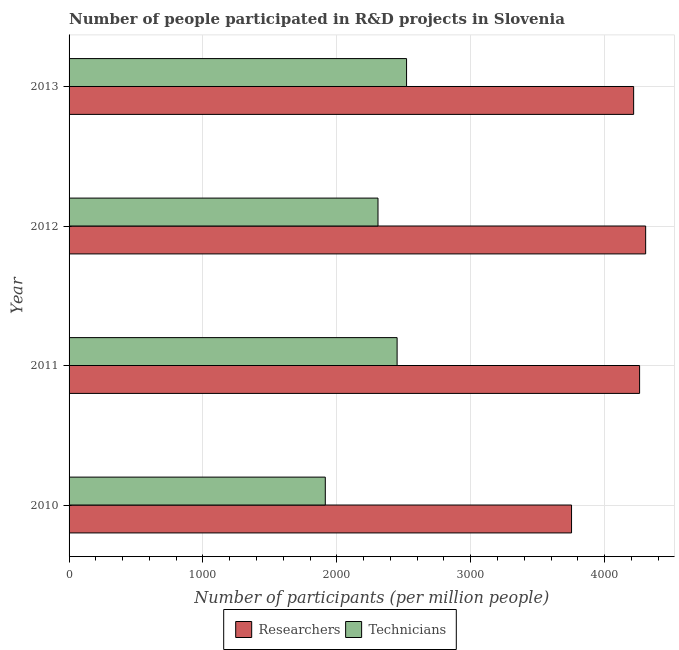How many different coloured bars are there?
Ensure brevity in your answer.  2. How many groups of bars are there?
Provide a succinct answer. 4. Are the number of bars per tick equal to the number of legend labels?
Make the answer very short. Yes. Are the number of bars on each tick of the Y-axis equal?
Keep it short and to the point. Yes. How many bars are there on the 4th tick from the top?
Provide a short and direct response. 2. How many bars are there on the 2nd tick from the bottom?
Keep it short and to the point. 2. What is the number of technicians in 2011?
Keep it short and to the point. 2450.19. Across all years, what is the maximum number of technicians?
Offer a very short reply. 2520.8. Across all years, what is the minimum number of technicians?
Make the answer very short. 1913.78. In which year was the number of researchers maximum?
Your answer should be very brief. 2012. In which year was the number of researchers minimum?
Provide a short and direct response. 2010. What is the total number of technicians in the graph?
Your answer should be very brief. 9192.23. What is the difference between the number of technicians in 2010 and that in 2013?
Your answer should be compact. -607.02. What is the difference between the number of researchers in 2012 and the number of technicians in 2010?
Make the answer very short. 2392.82. What is the average number of researchers per year?
Your answer should be very brief. 4134.42. In the year 2010, what is the difference between the number of technicians and number of researchers?
Keep it short and to the point. -1839.24. In how many years, is the number of researchers greater than 600 ?
Keep it short and to the point. 4. What is the ratio of the number of technicians in 2012 to that in 2013?
Offer a very short reply. 0.92. What is the difference between the highest and the second highest number of technicians?
Keep it short and to the point. 70.61. What is the difference between the highest and the lowest number of researchers?
Your answer should be very brief. 553.58. In how many years, is the number of researchers greater than the average number of researchers taken over all years?
Your answer should be very brief. 3. Is the sum of the number of researchers in 2011 and 2013 greater than the maximum number of technicians across all years?
Ensure brevity in your answer.  Yes. What does the 1st bar from the top in 2011 represents?
Give a very brief answer. Technicians. What does the 1st bar from the bottom in 2011 represents?
Your answer should be very brief. Researchers. What is the difference between two consecutive major ticks on the X-axis?
Give a very brief answer. 1000. Does the graph contain grids?
Your answer should be very brief. Yes. How many legend labels are there?
Your answer should be compact. 2. What is the title of the graph?
Keep it short and to the point. Number of people participated in R&D projects in Slovenia. Does "IMF concessional" appear as one of the legend labels in the graph?
Keep it short and to the point. No. What is the label or title of the X-axis?
Your answer should be compact. Number of participants (per million people). What is the Number of participants (per million people) of Researchers in 2010?
Provide a succinct answer. 3753.02. What is the Number of participants (per million people) of Technicians in 2010?
Ensure brevity in your answer.  1913.78. What is the Number of participants (per million people) in Researchers in 2011?
Keep it short and to the point. 4261.24. What is the Number of participants (per million people) of Technicians in 2011?
Provide a succinct answer. 2450.19. What is the Number of participants (per million people) in Researchers in 2012?
Offer a terse response. 4306.6. What is the Number of participants (per million people) in Technicians in 2012?
Give a very brief answer. 2307.45. What is the Number of participants (per million people) of Researchers in 2013?
Your response must be concise. 4216.83. What is the Number of participants (per million people) of Technicians in 2013?
Provide a succinct answer. 2520.8. Across all years, what is the maximum Number of participants (per million people) in Researchers?
Your answer should be very brief. 4306.6. Across all years, what is the maximum Number of participants (per million people) of Technicians?
Your answer should be compact. 2520.8. Across all years, what is the minimum Number of participants (per million people) in Researchers?
Provide a succinct answer. 3753.02. Across all years, what is the minimum Number of participants (per million people) in Technicians?
Provide a short and direct response. 1913.78. What is the total Number of participants (per million people) of Researchers in the graph?
Offer a very short reply. 1.65e+04. What is the total Number of participants (per million people) in Technicians in the graph?
Your answer should be compact. 9192.23. What is the difference between the Number of participants (per million people) in Researchers in 2010 and that in 2011?
Ensure brevity in your answer.  -508.22. What is the difference between the Number of participants (per million people) in Technicians in 2010 and that in 2011?
Ensure brevity in your answer.  -536.41. What is the difference between the Number of participants (per million people) in Researchers in 2010 and that in 2012?
Provide a succinct answer. -553.58. What is the difference between the Number of participants (per million people) in Technicians in 2010 and that in 2012?
Offer a very short reply. -393.67. What is the difference between the Number of participants (per million people) in Researchers in 2010 and that in 2013?
Provide a short and direct response. -463.81. What is the difference between the Number of participants (per million people) in Technicians in 2010 and that in 2013?
Keep it short and to the point. -607.02. What is the difference between the Number of participants (per million people) in Researchers in 2011 and that in 2012?
Provide a short and direct response. -45.35. What is the difference between the Number of participants (per million people) of Technicians in 2011 and that in 2012?
Provide a succinct answer. 142.74. What is the difference between the Number of participants (per million people) in Researchers in 2011 and that in 2013?
Your response must be concise. 44.41. What is the difference between the Number of participants (per million people) of Technicians in 2011 and that in 2013?
Your response must be concise. -70.61. What is the difference between the Number of participants (per million people) in Researchers in 2012 and that in 2013?
Offer a terse response. 89.76. What is the difference between the Number of participants (per million people) in Technicians in 2012 and that in 2013?
Your answer should be compact. -213.35. What is the difference between the Number of participants (per million people) in Researchers in 2010 and the Number of participants (per million people) in Technicians in 2011?
Keep it short and to the point. 1302.83. What is the difference between the Number of participants (per million people) in Researchers in 2010 and the Number of participants (per million people) in Technicians in 2012?
Offer a very short reply. 1445.57. What is the difference between the Number of participants (per million people) of Researchers in 2010 and the Number of participants (per million people) of Technicians in 2013?
Keep it short and to the point. 1232.22. What is the difference between the Number of participants (per million people) of Researchers in 2011 and the Number of participants (per million people) of Technicians in 2012?
Your response must be concise. 1953.79. What is the difference between the Number of participants (per million people) in Researchers in 2011 and the Number of participants (per million people) in Technicians in 2013?
Offer a very short reply. 1740.44. What is the difference between the Number of participants (per million people) of Researchers in 2012 and the Number of participants (per million people) of Technicians in 2013?
Provide a short and direct response. 1785.8. What is the average Number of participants (per million people) of Researchers per year?
Make the answer very short. 4134.42. What is the average Number of participants (per million people) in Technicians per year?
Provide a short and direct response. 2298.06. In the year 2010, what is the difference between the Number of participants (per million people) in Researchers and Number of participants (per million people) in Technicians?
Give a very brief answer. 1839.24. In the year 2011, what is the difference between the Number of participants (per million people) of Researchers and Number of participants (per million people) of Technicians?
Offer a terse response. 1811.05. In the year 2012, what is the difference between the Number of participants (per million people) in Researchers and Number of participants (per million people) in Technicians?
Make the answer very short. 1999.15. In the year 2013, what is the difference between the Number of participants (per million people) of Researchers and Number of participants (per million people) of Technicians?
Your response must be concise. 1696.03. What is the ratio of the Number of participants (per million people) of Researchers in 2010 to that in 2011?
Offer a terse response. 0.88. What is the ratio of the Number of participants (per million people) in Technicians in 2010 to that in 2011?
Offer a very short reply. 0.78. What is the ratio of the Number of participants (per million people) of Researchers in 2010 to that in 2012?
Provide a succinct answer. 0.87. What is the ratio of the Number of participants (per million people) of Technicians in 2010 to that in 2012?
Your answer should be very brief. 0.83. What is the ratio of the Number of participants (per million people) in Researchers in 2010 to that in 2013?
Offer a terse response. 0.89. What is the ratio of the Number of participants (per million people) of Technicians in 2010 to that in 2013?
Your response must be concise. 0.76. What is the ratio of the Number of participants (per million people) in Researchers in 2011 to that in 2012?
Provide a short and direct response. 0.99. What is the ratio of the Number of participants (per million people) in Technicians in 2011 to that in 2012?
Offer a very short reply. 1.06. What is the ratio of the Number of participants (per million people) in Researchers in 2011 to that in 2013?
Make the answer very short. 1.01. What is the ratio of the Number of participants (per million people) in Technicians in 2011 to that in 2013?
Offer a terse response. 0.97. What is the ratio of the Number of participants (per million people) in Researchers in 2012 to that in 2013?
Keep it short and to the point. 1.02. What is the ratio of the Number of participants (per million people) of Technicians in 2012 to that in 2013?
Ensure brevity in your answer.  0.92. What is the difference between the highest and the second highest Number of participants (per million people) in Researchers?
Ensure brevity in your answer.  45.35. What is the difference between the highest and the second highest Number of participants (per million people) in Technicians?
Your answer should be very brief. 70.61. What is the difference between the highest and the lowest Number of participants (per million people) in Researchers?
Your answer should be compact. 553.58. What is the difference between the highest and the lowest Number of participants (per million people) of Technicians?
Provide a succinct answer. 607.02. 